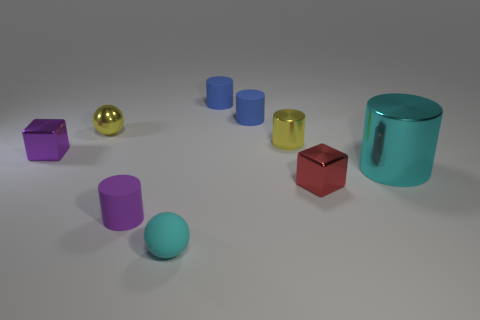There is a yellow sphere; what number of small metal cubes are to the right of it?
Keep it short and to the point. 1. Are there any tiny red cylinders made of the same material as the purple cylinder?
Your answer should be very brief. No. There is a yellow sphere that is the same size as the cyan matte thing; what is its material?
Give a very brief answer. Metal. There is a shiny object that is left of the yellow cylinder and behind the purple block; what is its size?
Provide a short and direct response. Small. There is a tiny cylinder that is both in front of the metallic sphere and behind the small purple rubber cylinder; what is its color?
Provide a short and direct response. Yellow. Is the number of purple things behind the big object less than the number of metal cylinders in front of the red shiny block?
Give a very brief answer. No. What number of other small metallic objects are the same shape as the small red metallic object?
Provide a succinct answer. 1. There is a cyan ball that is the same material as the tiny purple cylinder; what size is it?
Ensure brevity in your answer.  Small. What color is the tiny sphere in front of the tiny block on the left side of the small cyan matte sphere?
Provide a succinct answer. Cyan. Does the red shiny object have the same shape as the small yellow metallic object to the right of the small yellow metal sphere?
Offer a very short reply. No. 